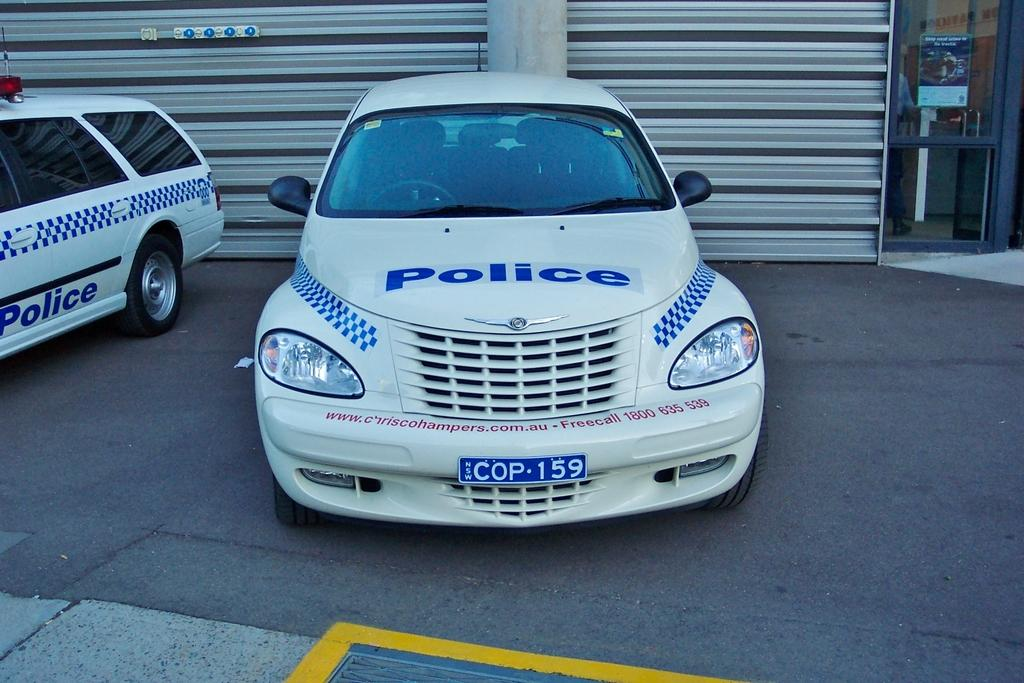<image>
Present a compact description of the photo's key features. A police car has the license plate COP-159. 